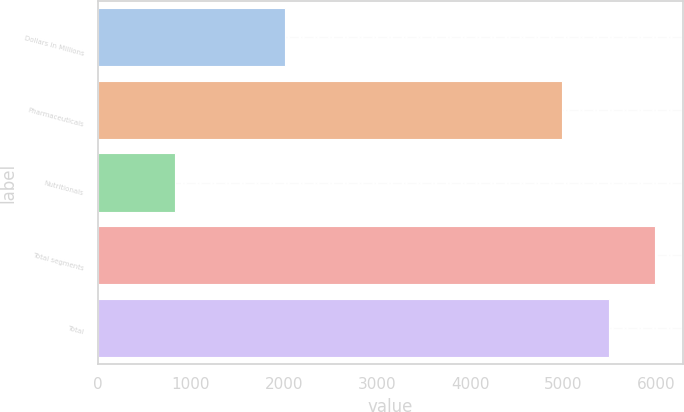<chart> <loc_0><loc_0><loc_500><loc_500><bar_chart><fcel>Dollars in Millions<fcel>Pharmaceuticals<fcel>Nutritionals<fcel>Total segments<fcel>Total<nl><fcel>2008<fcel>4988<fcel>830<fcel>5985.6<fcel>5486.8<nl></chart> 